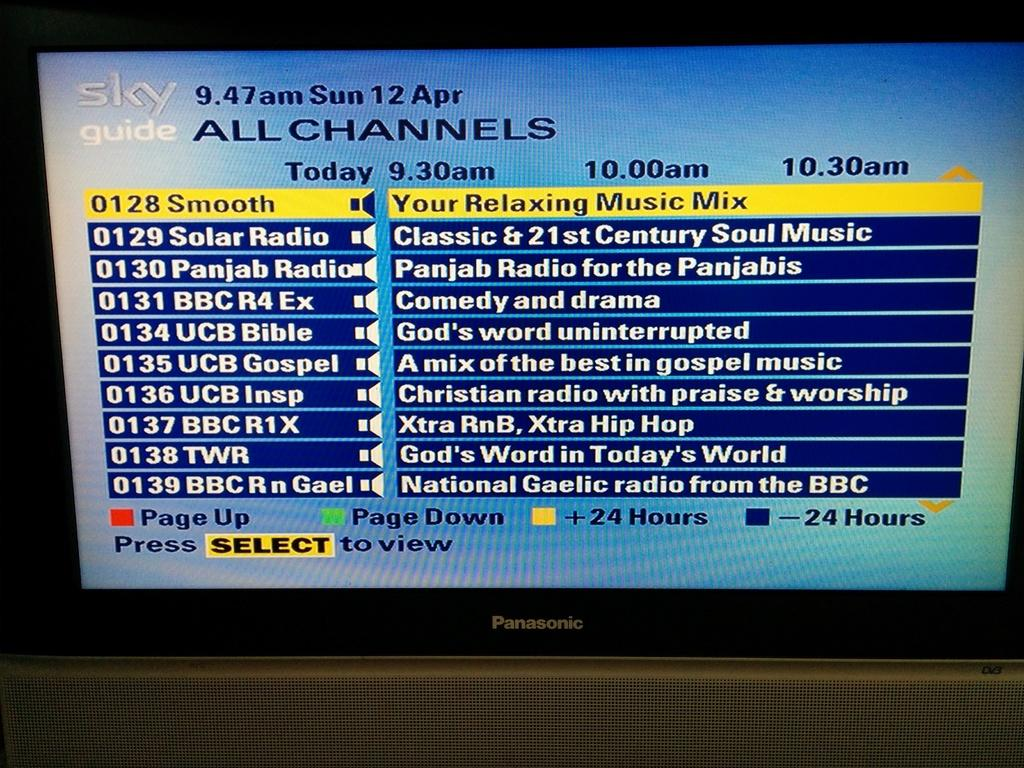<image>
Write a terse but informative summary of the picture. A screen displaying the "Sky Guide" and various music stations. 